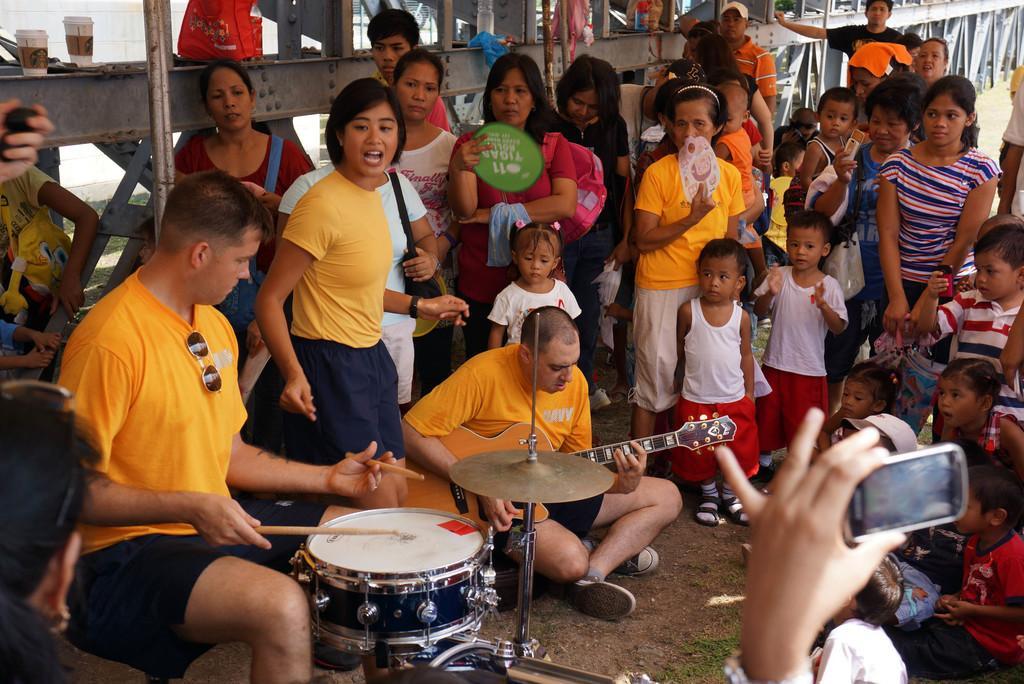Describe this image in one or two sentences. in this picture a man is sitting on a chair, he is playing musical drums he is wearing an yellow t-shirt. here is a man sitting on a ground, playing a guitar, and there are group of people standing. and here is a person talking a video on a phone. 